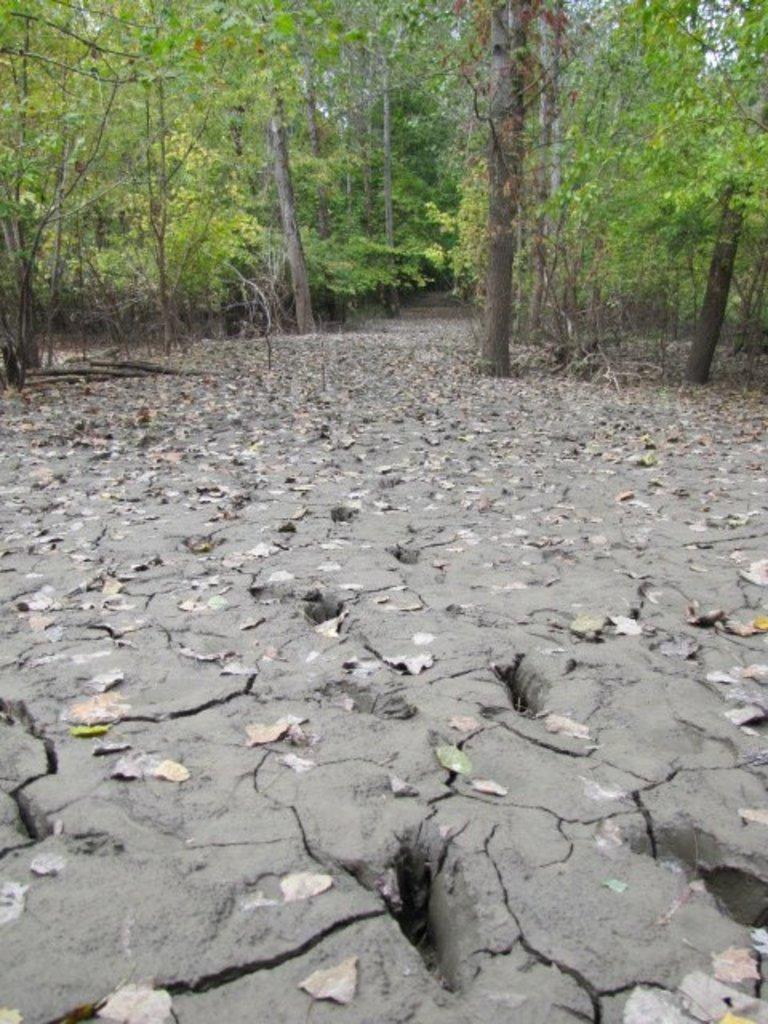Describe this image in one or two sentences. At the bottom of the image, we can see the leaves on the land. At the top of the image, we can see trees. 